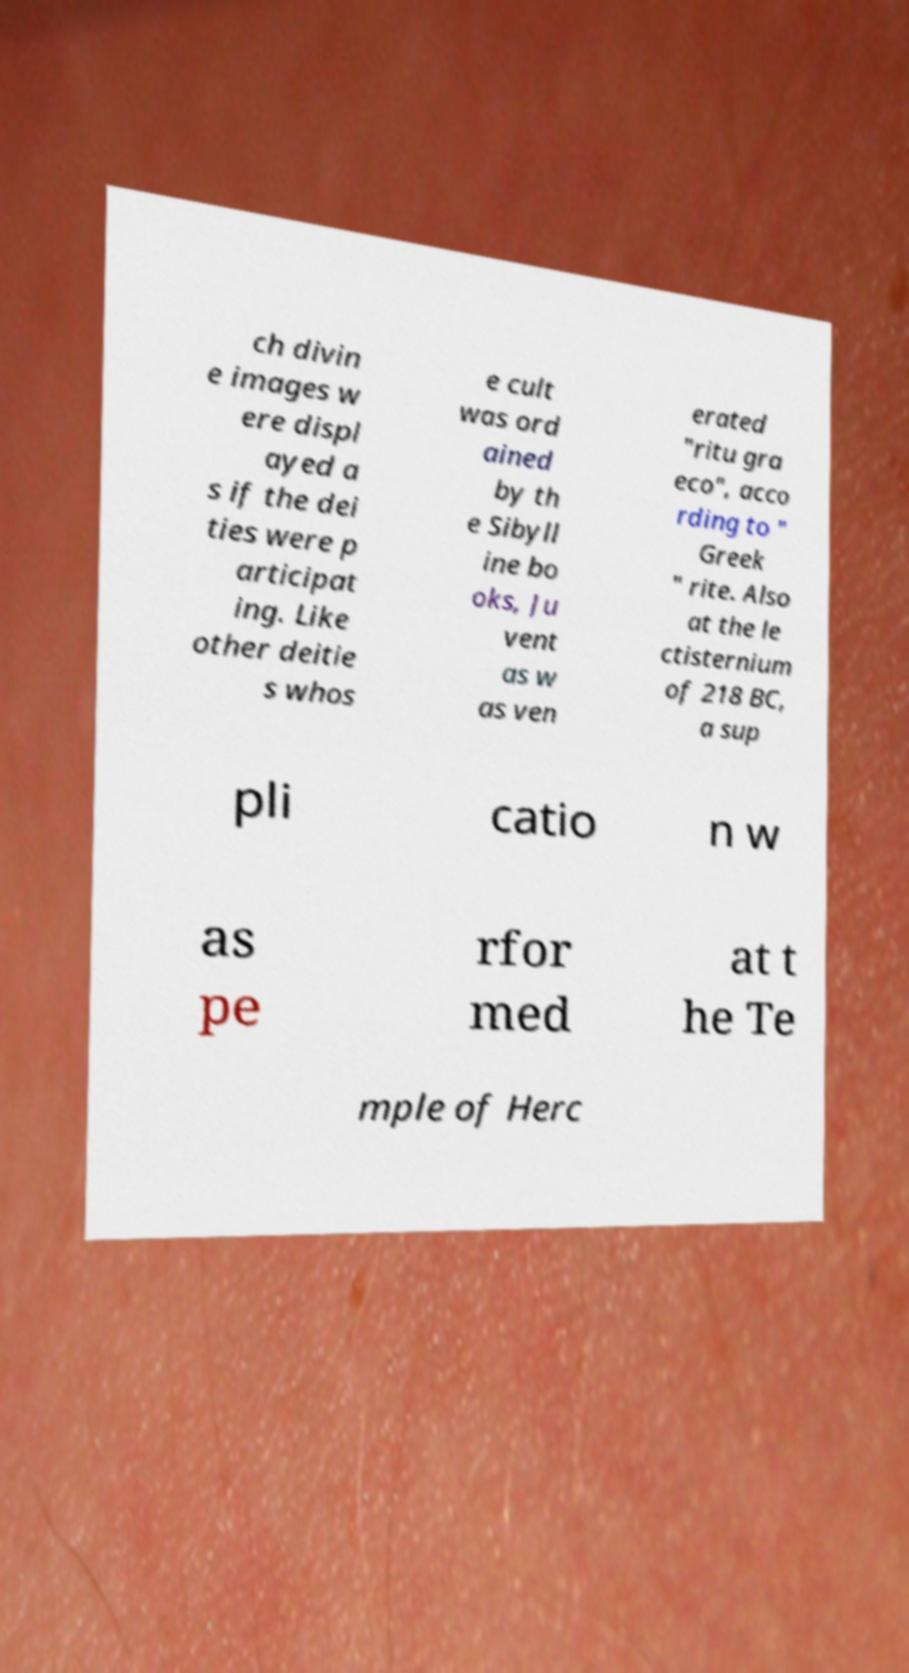Please read and relay the text visible in this image. What does it say? ch divin e images w ere displ ayed a s if the dei ties were p articipat ing. Like other deitie s whos e cult was ord ained by th e Sibyll ine bo oks, Ju vent as w as ven erated "ritu gra eco", acco rding to " Greek " rite. Also at the le ctisternium of 218 BC, a sup pli catio n w as pe rfor med at t he Te mple of Herc 